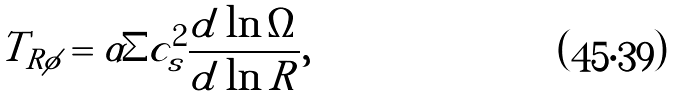<formula> <loc_0><loc_0><loc_500><loc_500>T _ { R \phi } = \alpha \Sigma c _ { s } ^ { 2 } \frac { d \ln \Omega } { d \ln R } ,</formula> 